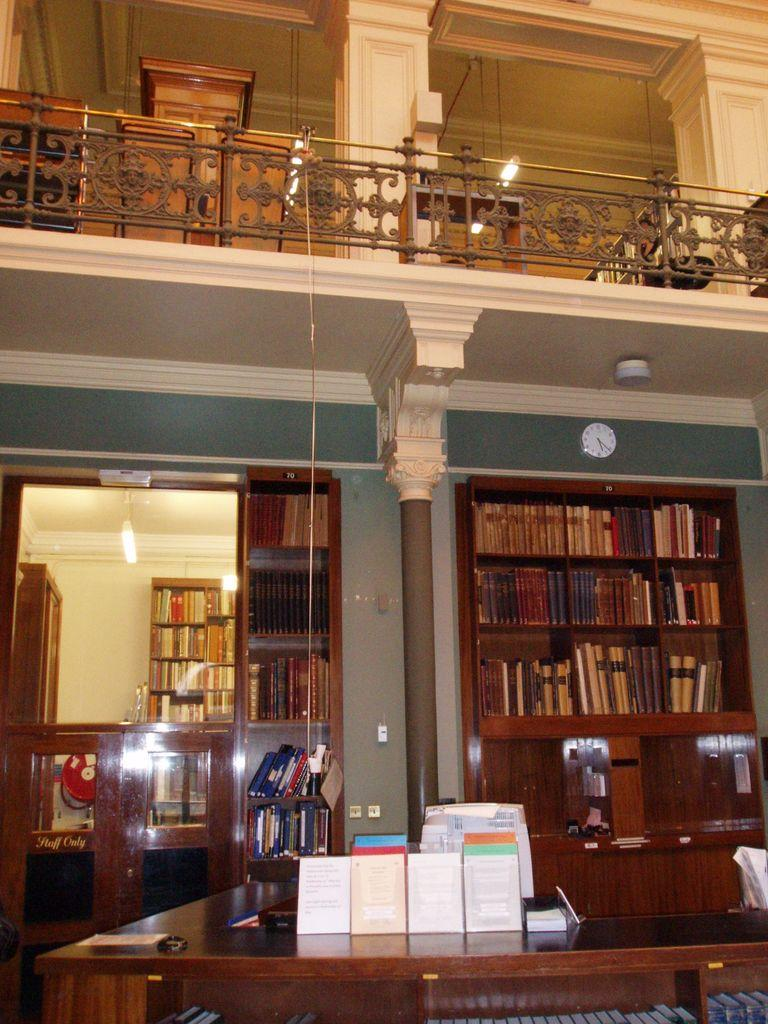What is the main piece of furniture in the image? There is a table in the image. What items are placed on the table? There are books on the table. What can be seen in the background of the image? There are bookshelves at the back of the image. How far away is the representative from the board in the image? There is no representative or board present in the image. 